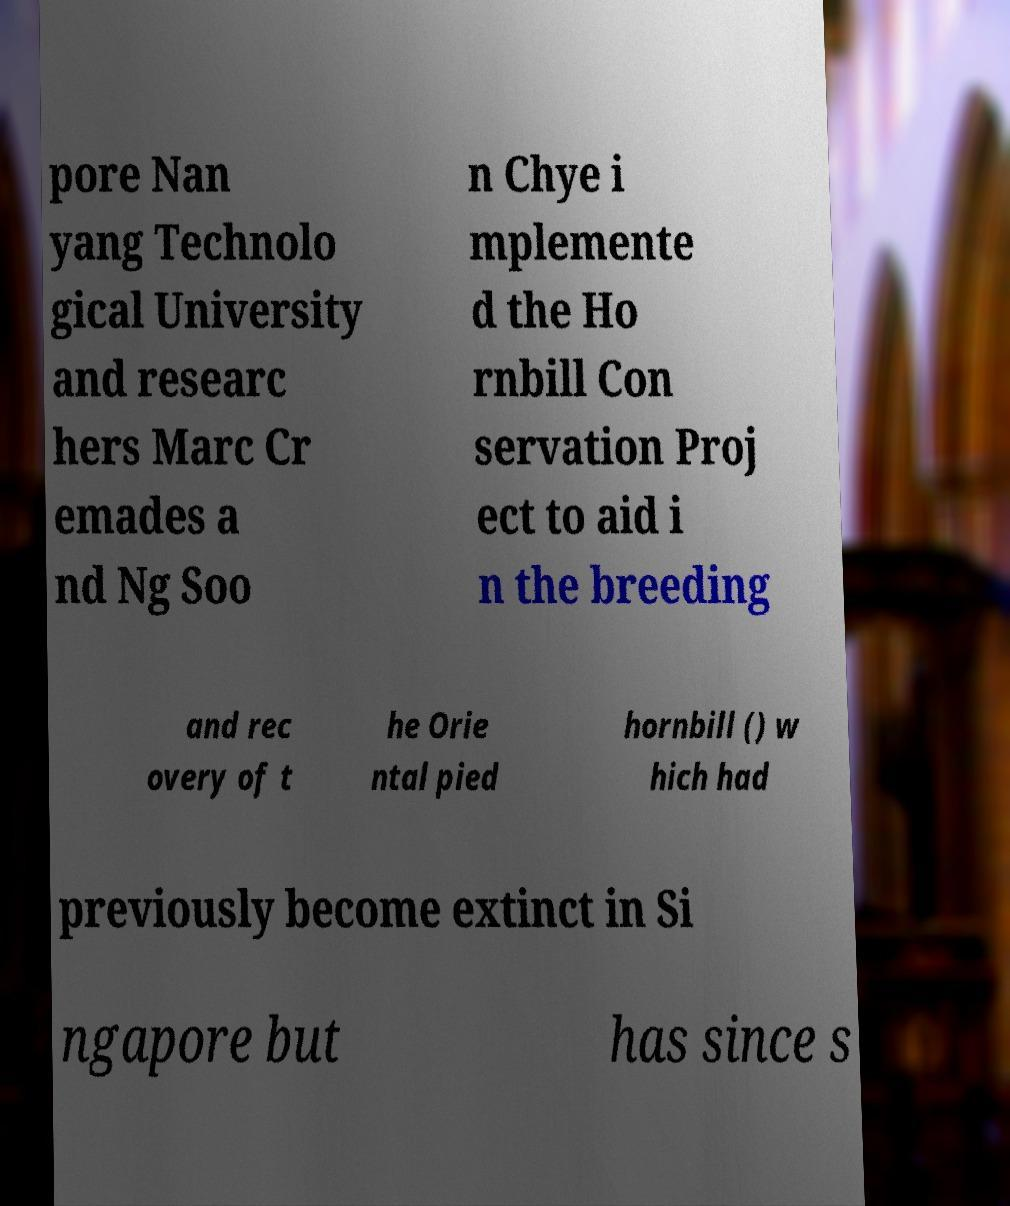Please identify and transcribe the text found in this image. pore Nan yang Technolo gical University and researc hers Marc Cr emades a nd Ng Soo n Chye i mplemente d the Ho rnbill Con servation Proj ect to aid i n the breeding and rec overy of t he Orie ntal pied hornbill () w hich had previously become extinct in Si ngapore but has since s 